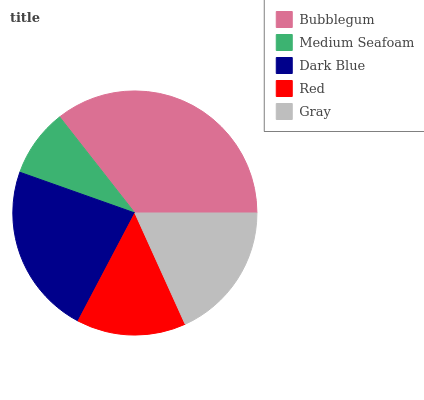Is Medium Seafoam the minimum?
Answer yes or no. Yes. Is Bubblegum the maximum?
Answer yes or no. Yes. Is Dark Blue the minimum?
Answer yes or no. No. Is Dark Blue the maximum?
Answer yes or no. No. Is Dark Blue greater than Medium Seafoam?
Answer yes or no. Yes. Is Medium Seafoam less than Dark Blue?
Answer yes or no. Yes. Is Medium Seafoam greater than Dark Blue?
Answer yes or no. No. Is Dark Blue less than Medium Seafoam?
Answer yes or no. No. Is Gray the high median?
Answer yes or no. Yes. Is Gray the low median?
Answer yes or no. Yes. Is Dark Blue the high median?
Answer yes or no. No. Is Dark Blue the low median?
Answer yes or no. No. 